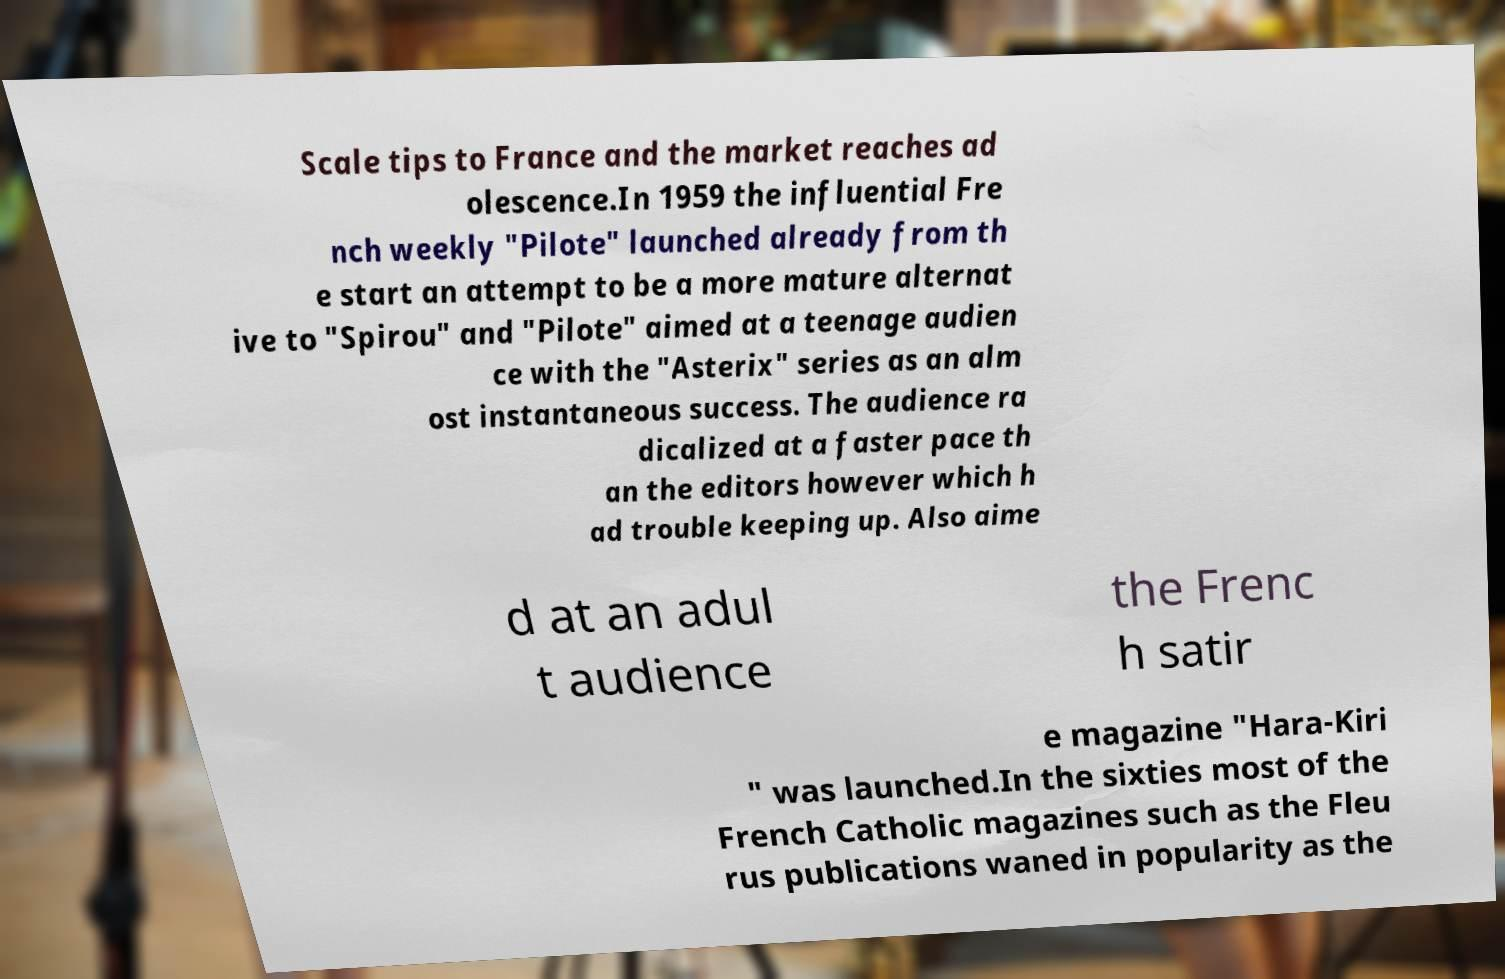What messages or text are displayed in this image? I need them in a readable, typed format. Scale tips to France and the market reaches ad olescence.In 1959 the influential Fre nch weekly "Pilote" launched already from th e start an attempt to be a more mature alternat ive to "Spirou" and "Pilote" aimed at a teenage audien ce with the "Asterix" series as an alm ost instantaneous success. The audience ra dicalized at a faster pace th an the editors however which h ad trouble keeping up. Also aime d at an adul t audience the Frenc h satir e magazine "Hara-Kiri " was launched.In the sixties most of the French Catholic magazines such as the Fleu rus publications waned in popularity as the 